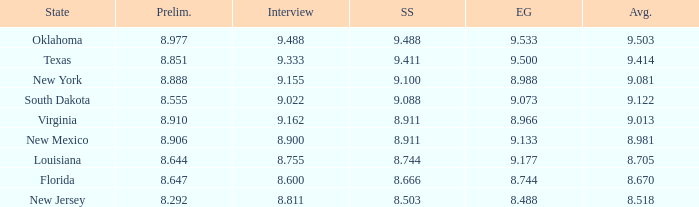 what's the preliminaries where evening gown is 8.988 8.888. 